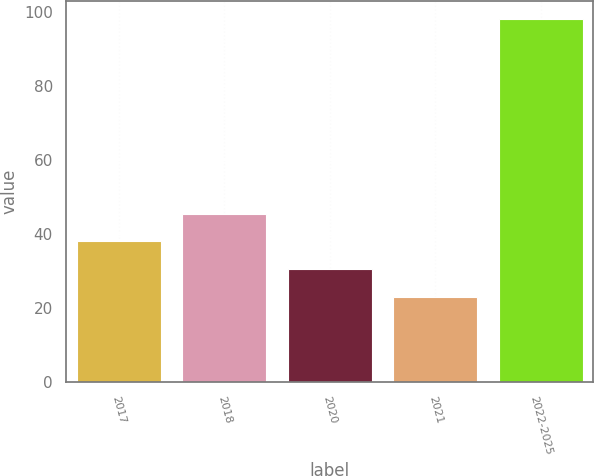Convert chart to OTSL. <chart><loc_0><loc_0><loc_500><loc_500><bar_chart><fcel>2017<fcel>2018<fcel>2020<fcel>2021<fcel>2022-2025<nl><fcel>38<fcel>45.5<fcel>30.5<fcel>23<fcel>98<nl></chart> 